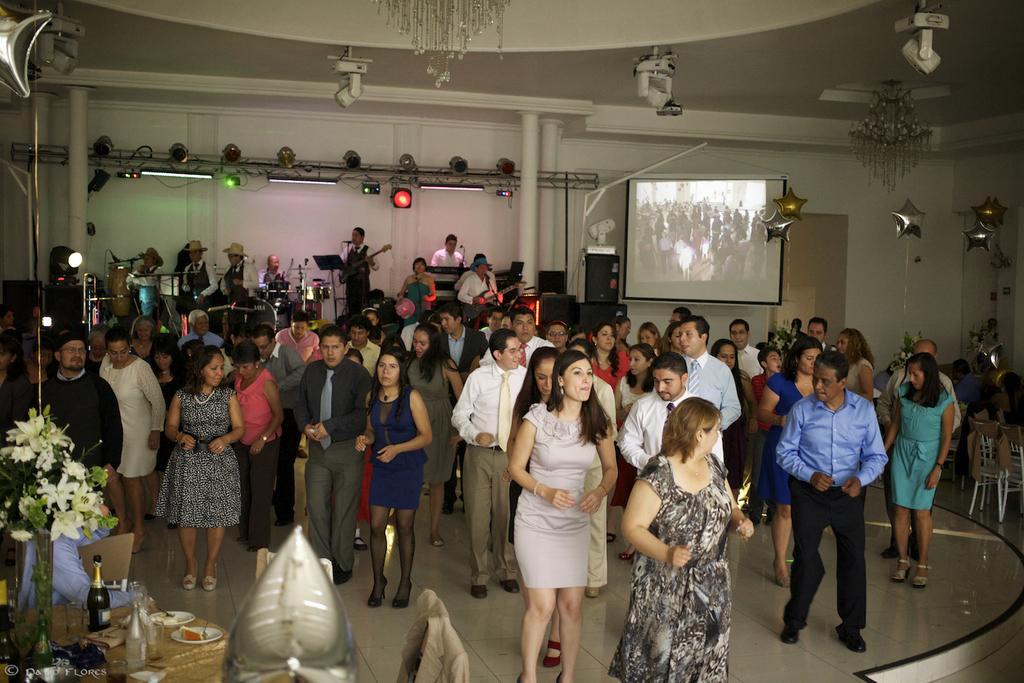In one or two sentences, can you explain what this image depicts? At the top we can see ceiling, chandeliers. We can see screen, decorative star balloons, people playing instruments. We can see people dancing on the floor. In the bottom left corner of the picture we can see a flower vase, bottles, food in the plates, glass is also visible on the table. On the right side of the picture we can see chairs. 